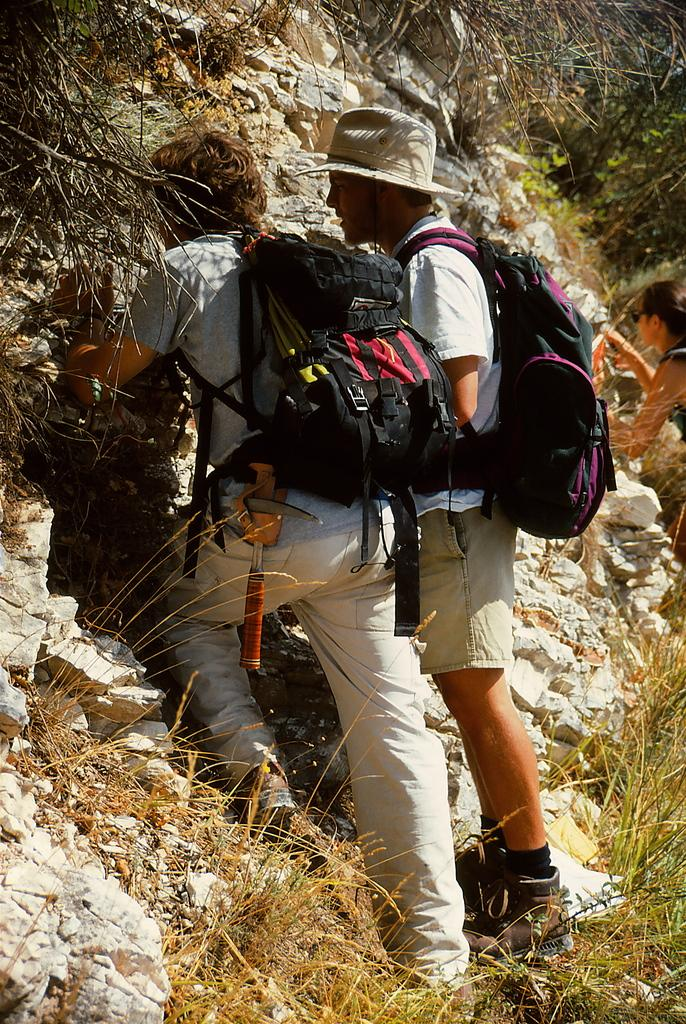How many people are in the image? There are two people in the image. What are the people doing in the image? The people are carrying bags and standing. What can be seen in the background of the image? There is a hill visible in the image. What type of vegetation is present in the image? There is grass in the image. What type of flame can be seen on the sheet in the image? There is no flame or sheet present in the image. 